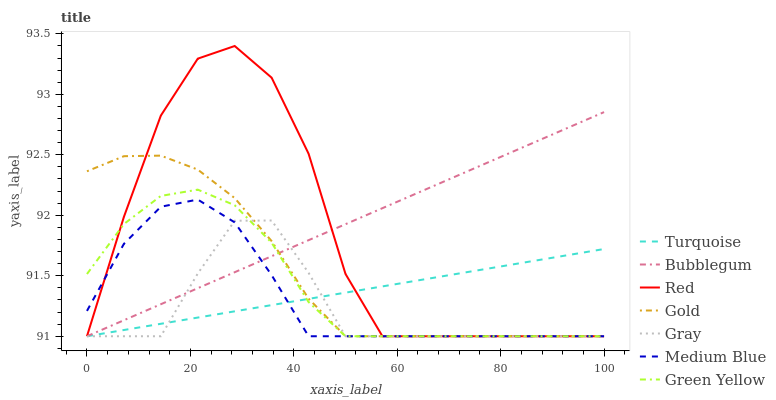Does Turquoise have the minimum area under the curve?
Answer yes or no. No. Does Turquoise have the maximum area under the curve?
Answer yes or no. No. Is Turquoise the smoothest?
Answer yes or no. No. Is Turquoise the roughest?
Answer yes or no. No. Does Gold have the highest value?
Answer yes or no. No. 